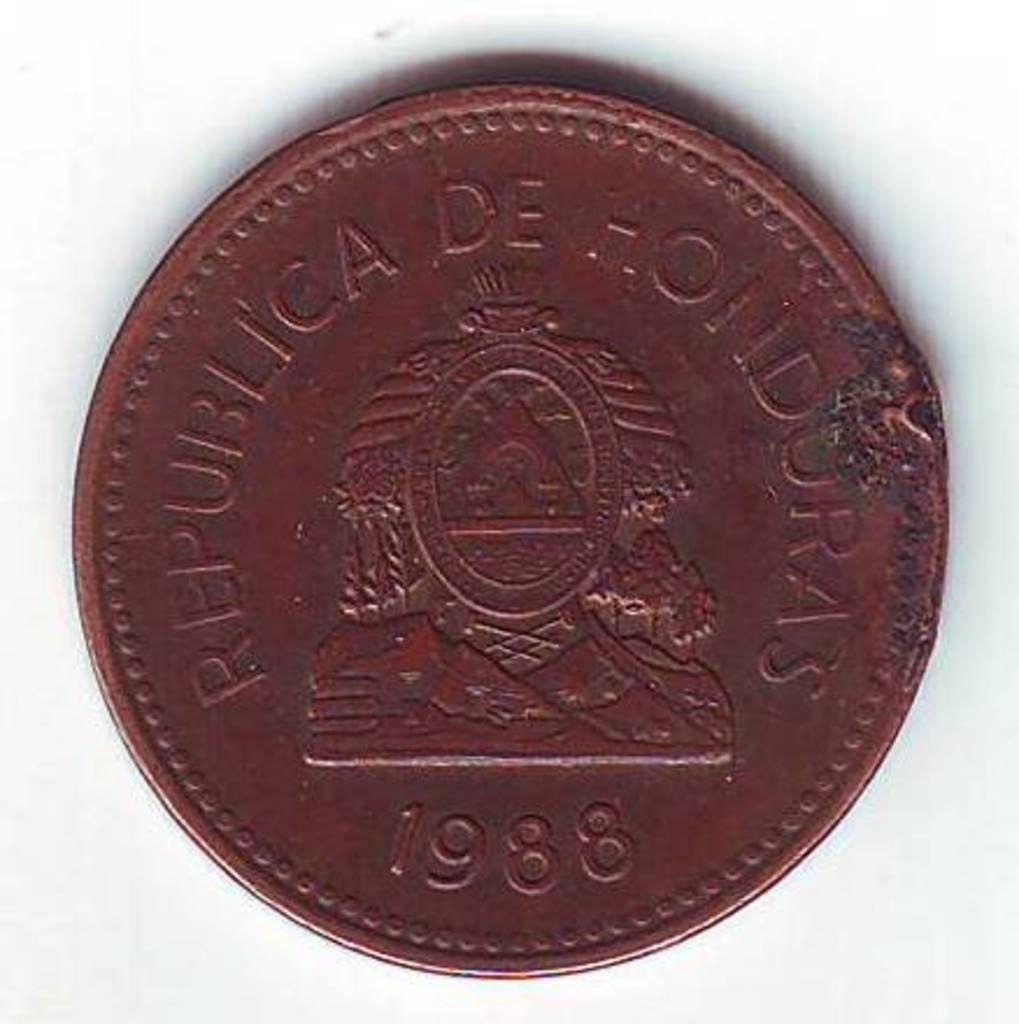<image>
Provide a brief description of the given image. A dark coin labeled Republica de Hondorus 1988 is laying on a white background. 